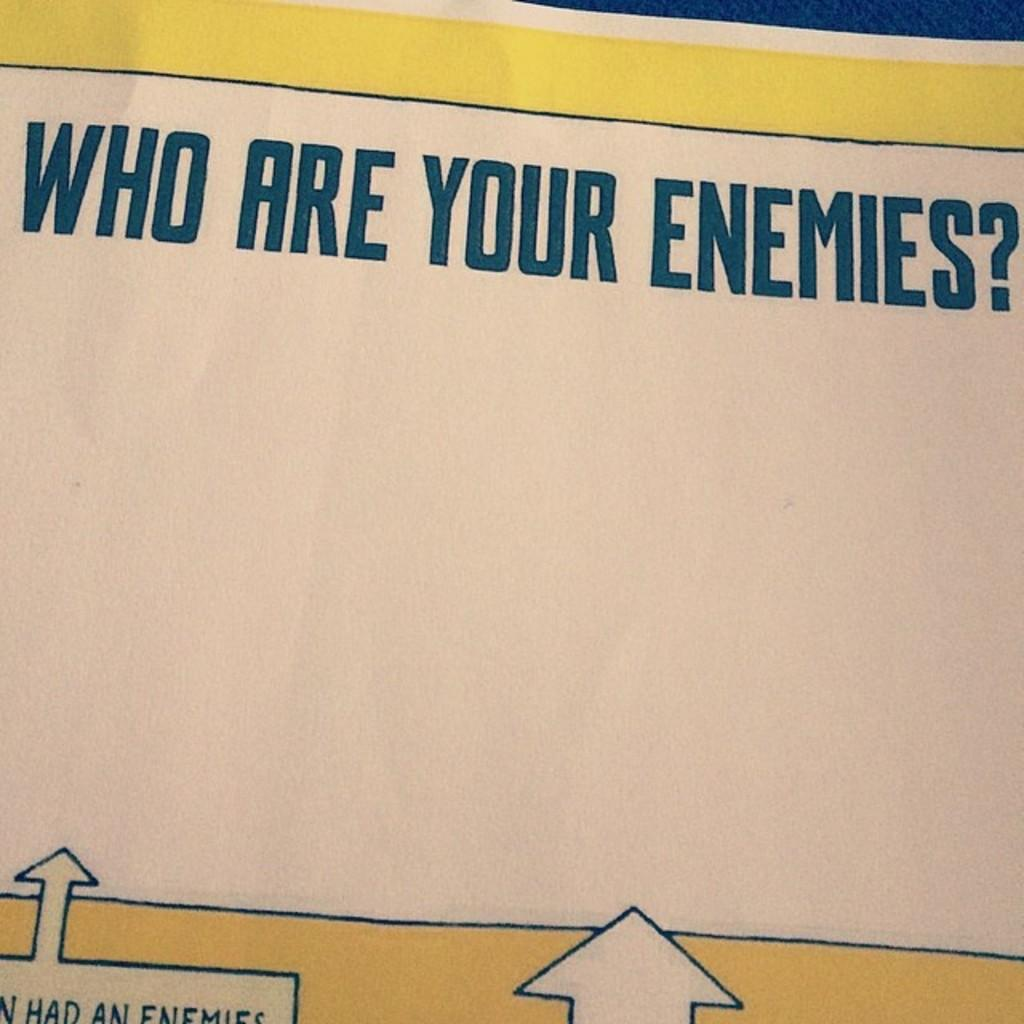<image>
Give a short and clear explanation of the subsequent image. A circle in the center and the question who are your enemies. 